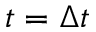Convert formula to latex. <formula><loc_0><loc_0><loc_500><loc_500>t = \Delta t</formula> 